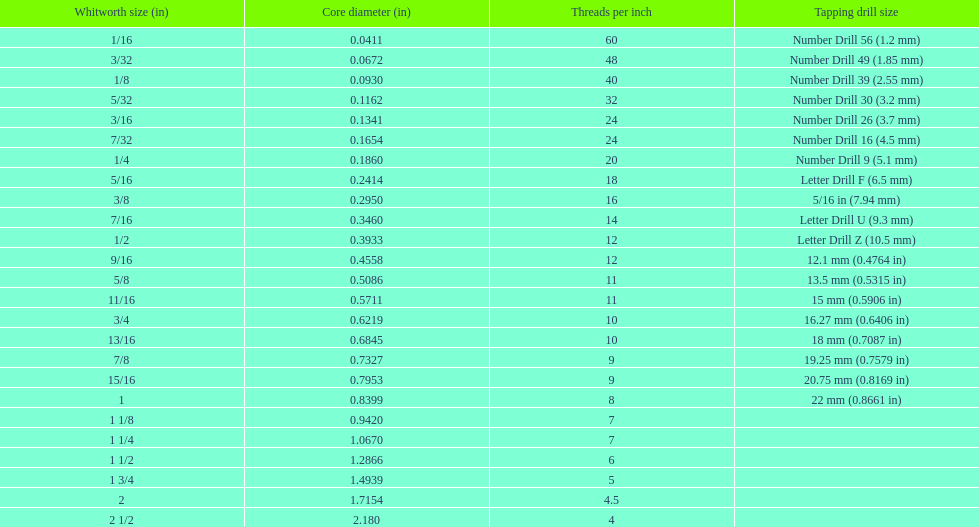After 0.1162. 